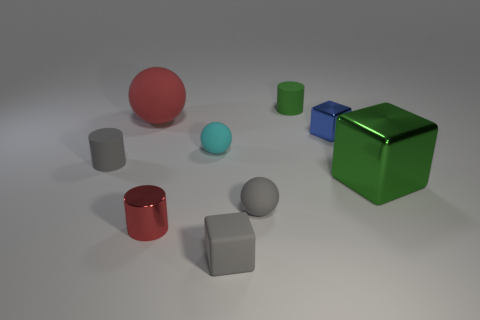Add 1 large rubber things. How many objects exist? 10 Subtract all rubber cylinders. How many cylinders are left? 1 Subtract all cubes. How many objects are left? 6 Subtract all small blue cylinders. Subtract all red things. How many objects are left? 7 Add 3 cubes. How many cubes are left? 6 Add 6 big blue cylinders. How many big blue cylinders exist? 6 Subtract 1 cyan balls. How many objects are left? 8 Subtract all green blocks. Subtract all red balls. How many blocks are left? 2 